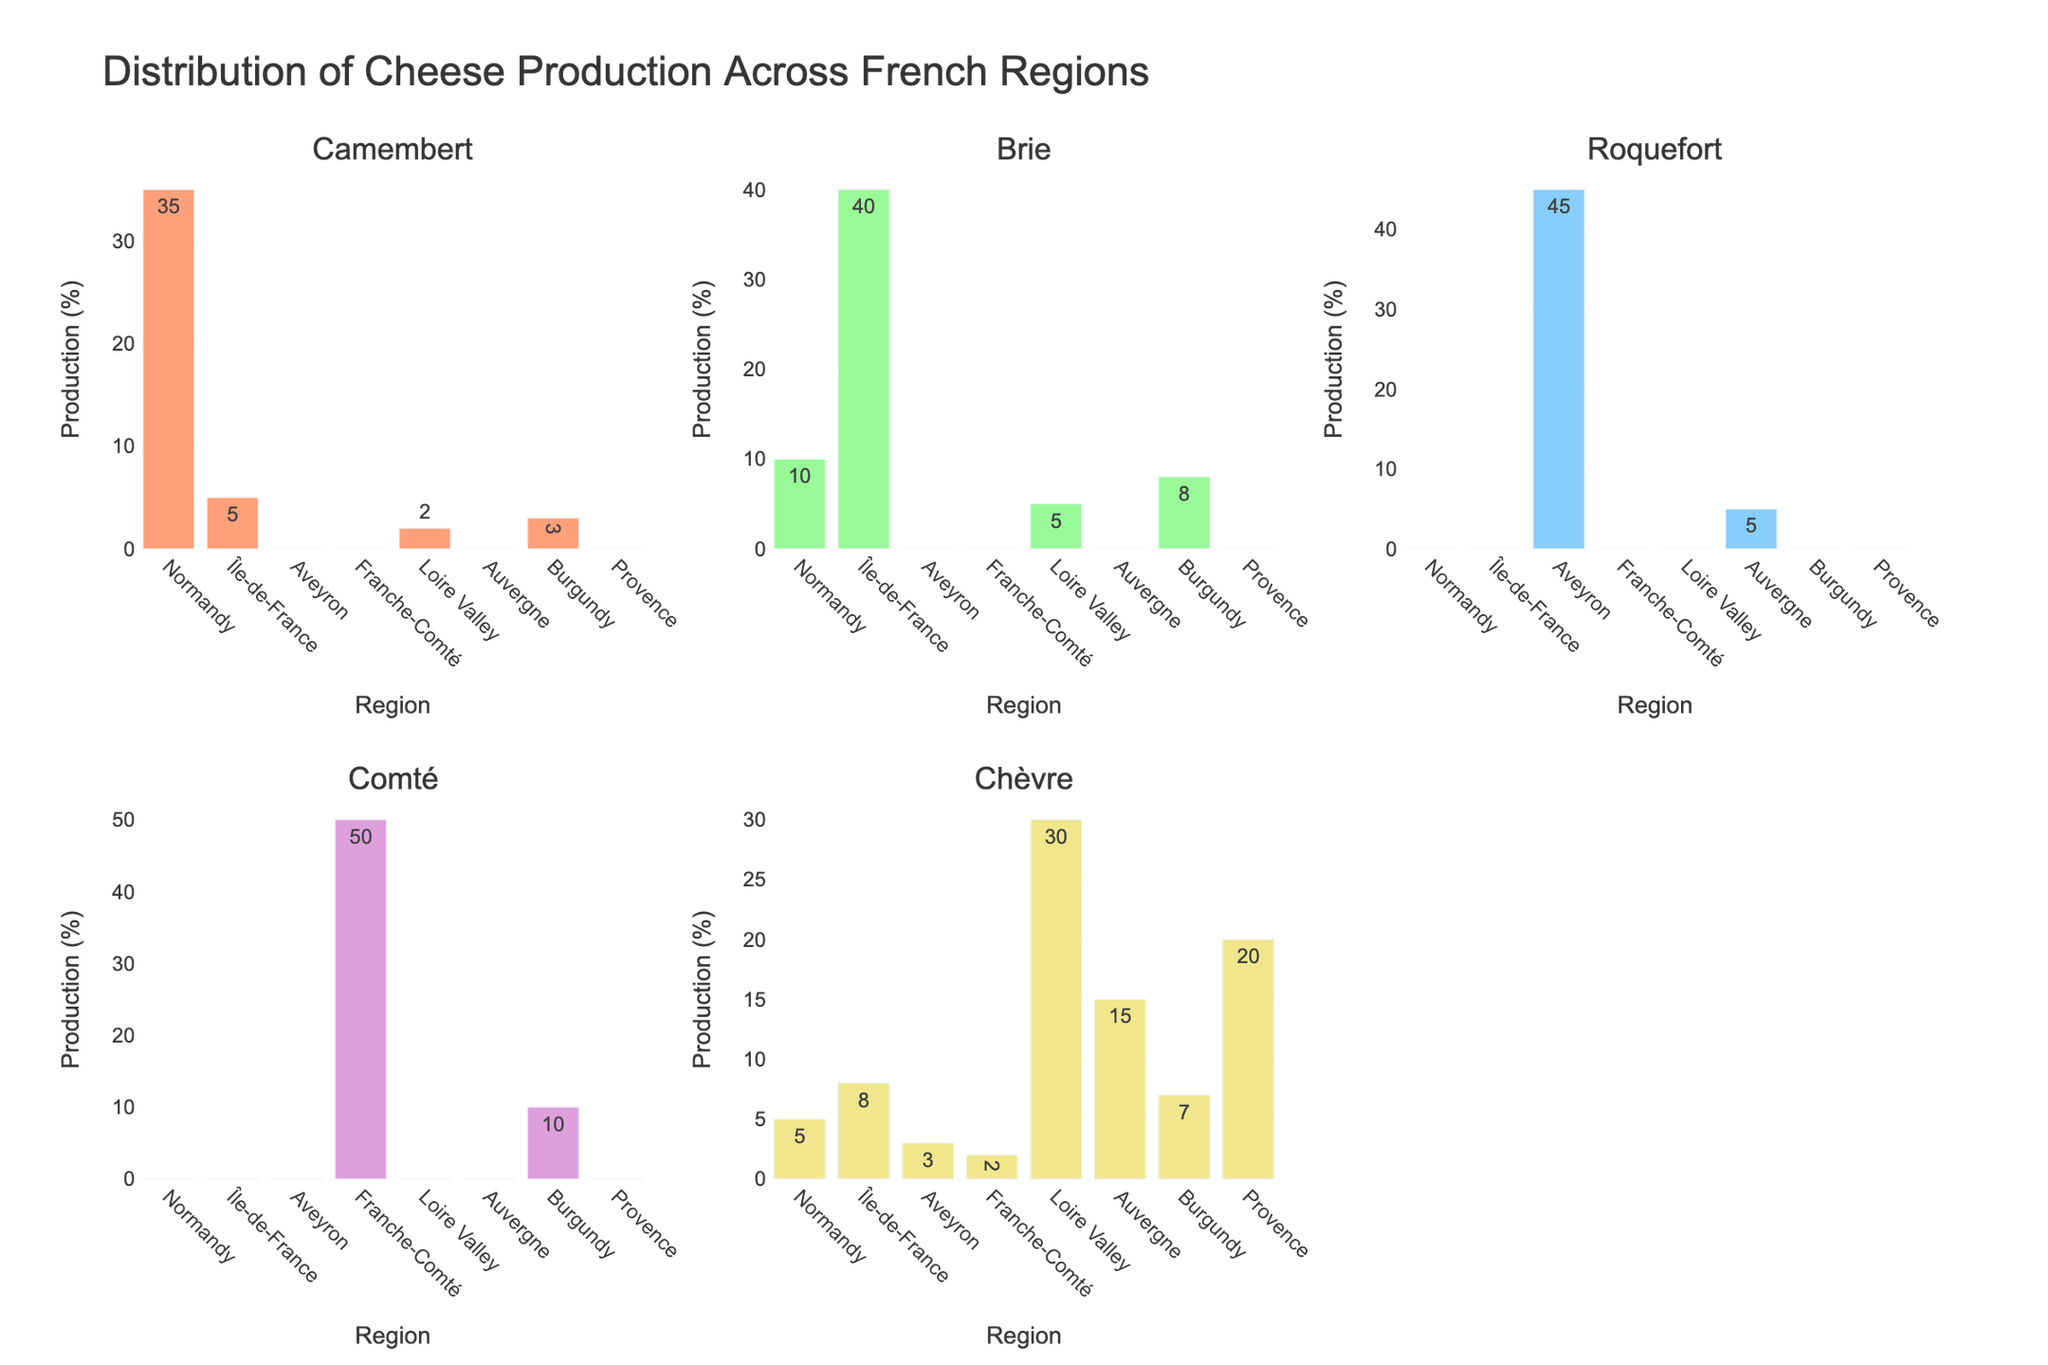What's the title of the plot? The title is written at the top of the plot, and it is visible without much effort.
Answer: Distribution of Cheese Production Across French Regions What color represents Brie production in the figure? Different cheese types are represented by bars in distinct colors, which can be identified by looking at the bar labeled "Brie".
Answer: Light green Which region produces the most Comté cheese? The tallest bar in the Comté cheese subplot indicates the region with the highest production.
Answer: Franche-Comté What's the total production of cheese in Île-de-France? By summing the heights of all bars corresponding to Île-de-France across all subplots, we get the total production. Calculation: 5 (Camembert) + 40 (Brie) + 0 (Roquefort) + 0 (Comté) + 8 (Chèvre)
Answer: 53 Is there any region that doesn't produce any Camembert cheese? By looking at the Camembert subplot and finding the regions with zero height bars, we identify these regions.
Answer: Aveyron, Franche-Comté, Auvergne, Provence Which cheese has the least number of regions producing it? By counting the number of regions bars in each subplot, the cheese with the fewest bars indicates the least number of regions producing it.
Answer: Roquefort Compare the production of Chèvre cheese in Loire Valley and Provence. Which one is higher? By comparing the heights of the bars in the Chèvre subplot for both regions, we determine which one is taller.
Answer: Loire Valley What is the sum of Roquefort and Camembert production in Normandy? By adding the values in the Roquefort and Camembert subplots for the Normandy region. Calculation: 0 (Roquefort) + 35 (Camembert)
Answer: 35 How many cheese types are produced in Burgundy? By counting non-zero bars in each subplot for the Burgundy region, we get the number of cheese types produced there.
Answer: 4 Which region has the highest diversity in cheese production? By identifying the region with the most number of non-zero bars across all subplots, we determine the region with the highest diversity.
Answer: Burgundy 